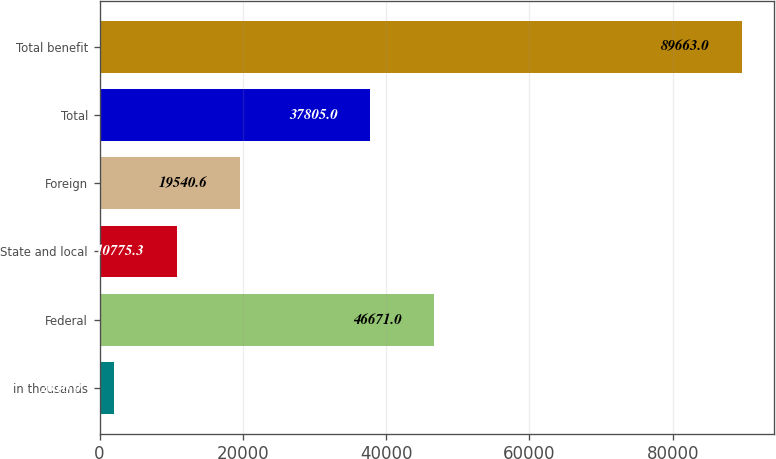Convert chart. <chart><loc_0><loc_0><loc_500><loc_500><bar_chart><fcel>in thousands<fcel>Federal<fcel>State and local<fcel>Foreign<fcel>Total<fcel>Total benefit<nl><fcel>2010<fcel>46671<fcel>10775.3<fcel>19540.6<fcel>37805<fcel>89663<nl></chart> 